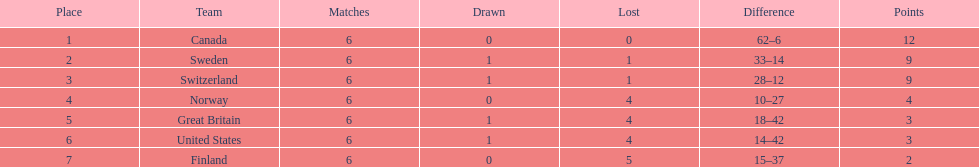Which country performed better during the 1951 world ice hockey championships, switzerland or great britain? Switzerland. 